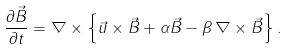Convert formula to latex. <formula><loc_0><loc_0><loc_500><loc_500>\frac { \partial \vec { B } } { \partial t } = \nabla \times \left \{ \vec { u } \times \vec { B } + \alpha \vec { B } - \beta \, \nabla \times \vec { B } \right \} .</formula> 